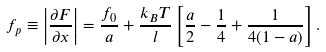<formula> <loc_0><loc_0><loc_500><loc_500>f _ { p } \equiv \left | \frac { \partial F } { \partial x } \right | = \frac { f _ { 0 } } { a } + \frac { k _ { B } T } { l } \left [ \frac { a } { 2 } - \frac { 1 } { 4 } + \frac { 1 } { 4 ( 1 - a ) } \right ] .</formula> 